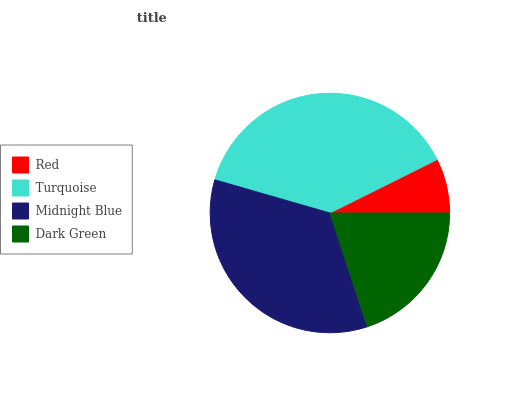Is Red the minimum?
Answer yes or no. Yes. Is Turquoise the maximum?
Answer yes or no. Yes. Is Midnight Blue the minimum?
Answer yes or no. No. Is Midnight Blue the maximum?
Answer yes or no. No. Is Turquoise greater than Midnight Blue?
Answer yes or no. Yes. Is Midnight Blue less than Turquoise?
Answer yes or no. Yes. Is Midnight Blue greater than Turquoise?
Answer yes or no. No. Is Turquoise less than Midnight Blue?
Answer yes or no. No. Is Midnight Blue the high median?
Answer yes or no. Yes. Is Dark Green the low median?
Answer yes or no. Yes. Is Dark Green the high median?
Answer yes or no. No. Is Red the low median?
Answer yes or no. No. 